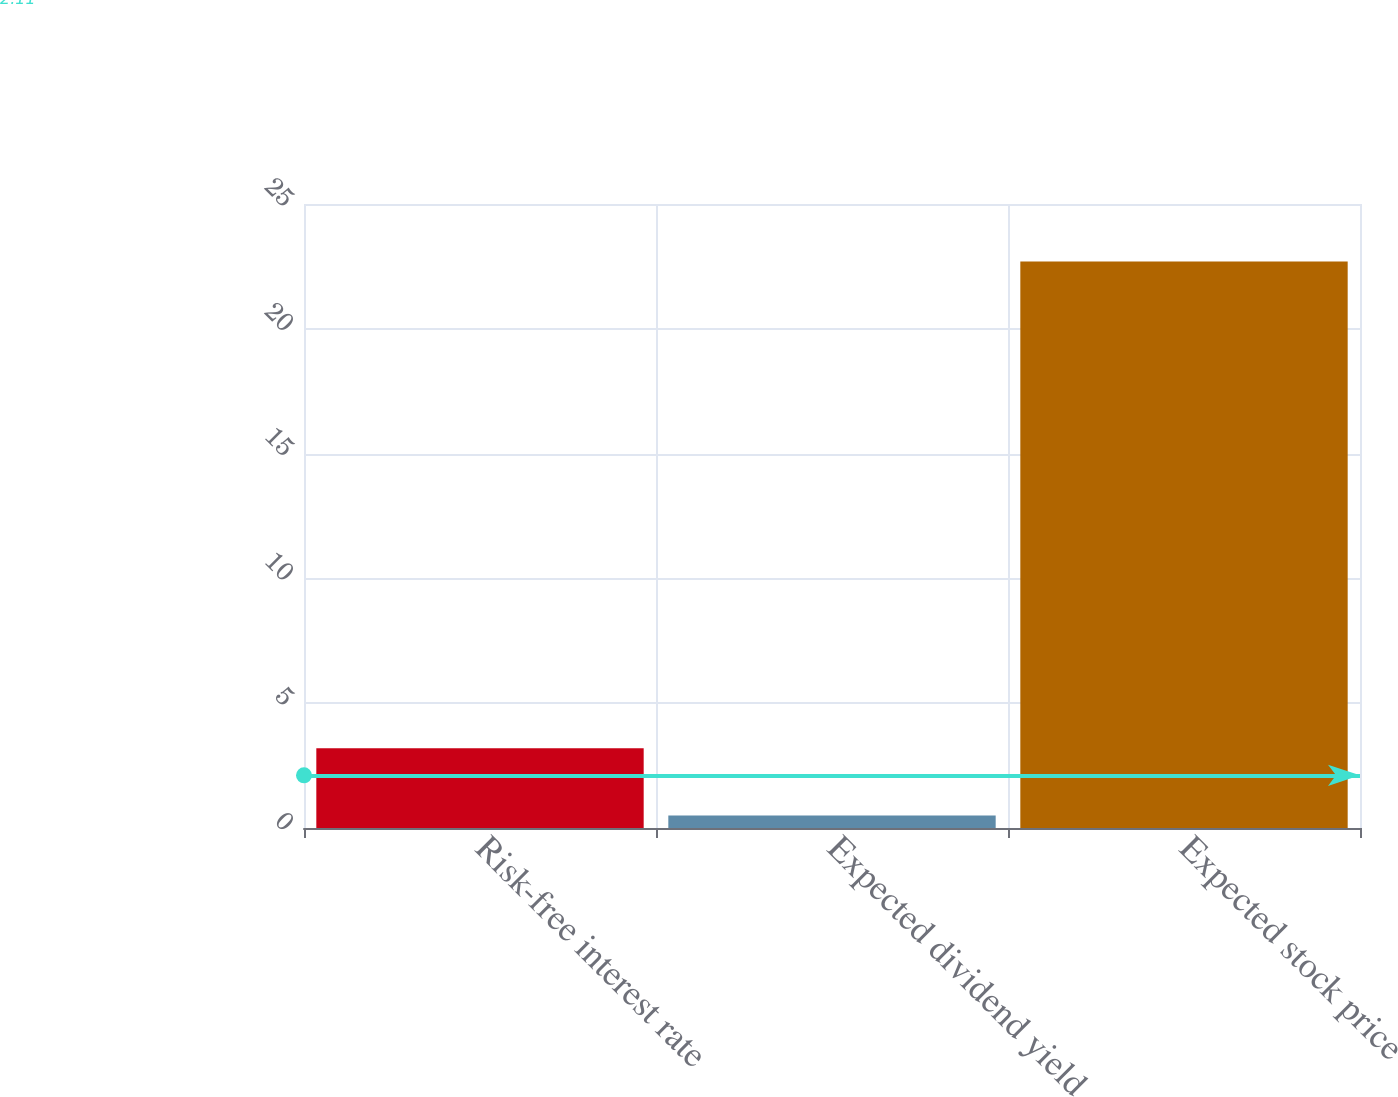Convert chart. <chart><loc_0><loc_0><loc_500><loc_500><bar_chart><fcel>Risk-free interest rate<fcel>Expected dividend yield<fcel>Expected stock price<nl><fcel>3.2<fcel>0.5<fcel>22.7<nl></chart> 